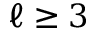Convert formula to latex. <formula><loc_0><loc_0><loc_500><loc_500>\ell \geq 3</formula> 